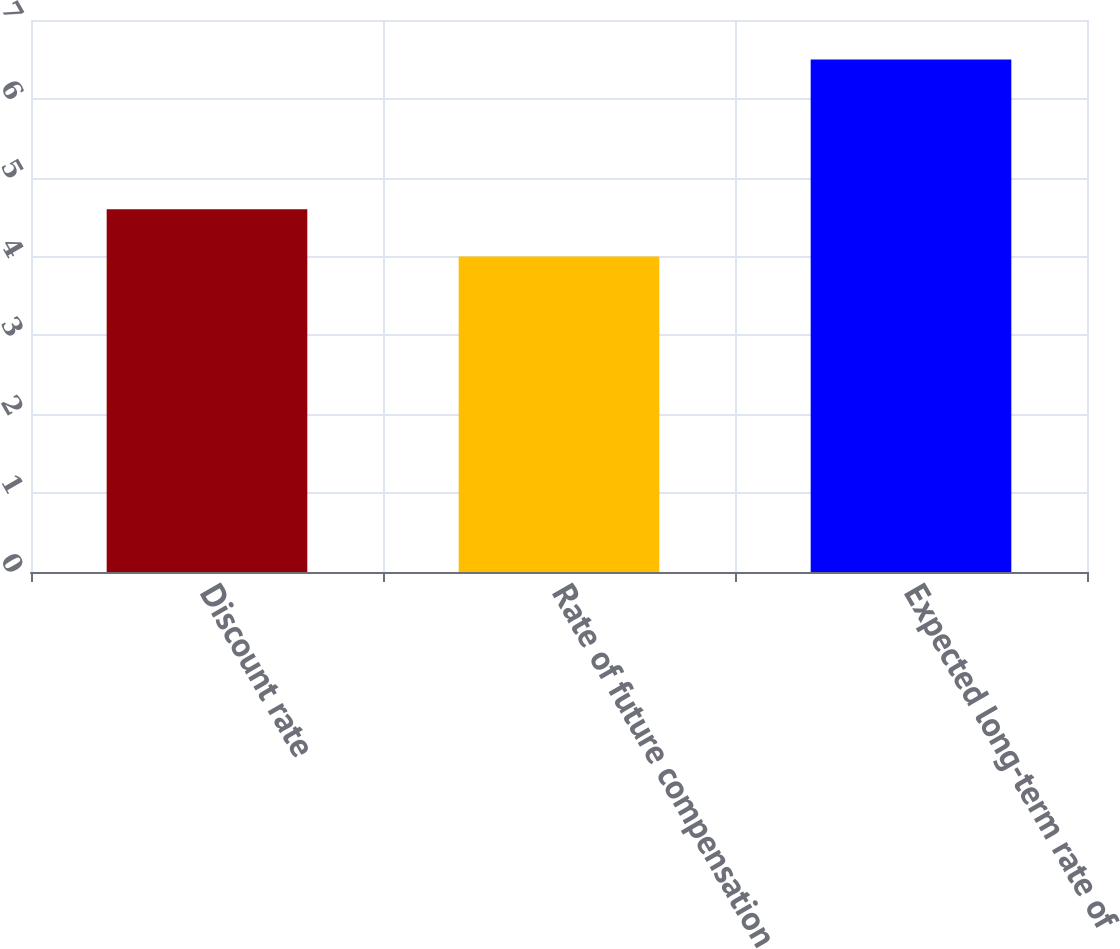<chart> <loc_0><loc_0><loc_500><loc_500><bar_chart><fcel>Discount rate<fcel>Rate of future compensation<fcel>Expected long-term rate of<nl><fcel>4.6<fcel>4<fcel>6.5<nl></chart> 